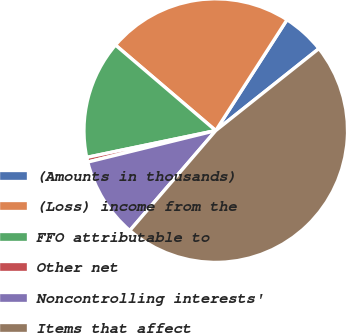Convert chart. <chart><loc_0><loc_0><loc_500><loc_500><pie_chart><fcel>(Amounts in thousands)<fcel>(Loss) income from the<fcel>FFO attributable to<fcel>Other net<fcel>Noncontrolling interests'<fcel>Items that affect<nl><fcel>5.22%<fcel>22.85%<fcel>14.5%<fcel>0.58%<fcel>9.86%<fcel>46.99%<nl></chart> 